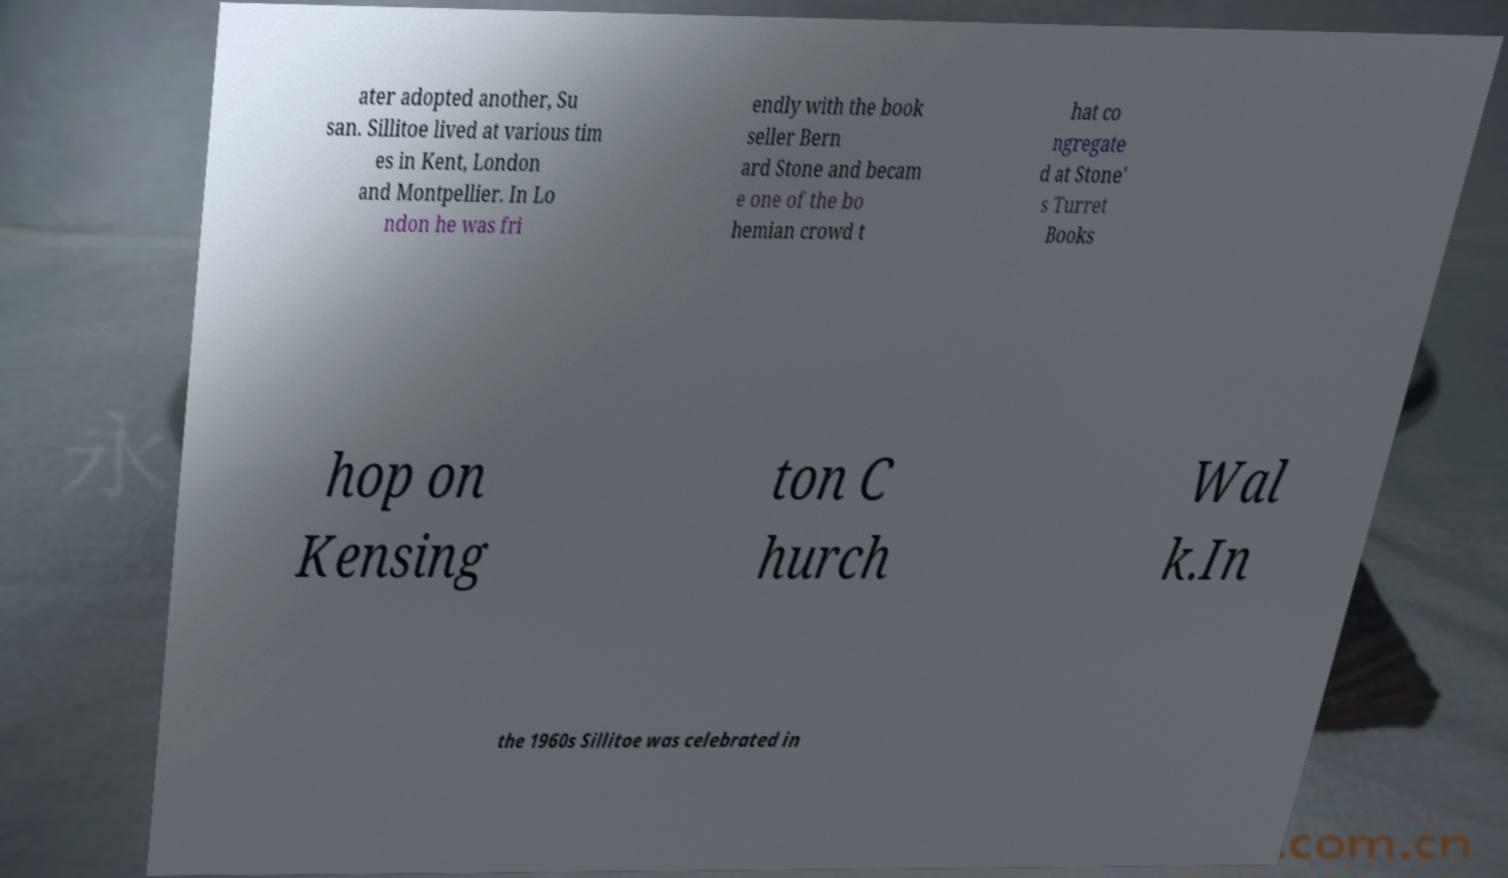There's text embedded in this image that I need extracted. Can you transcribe it verbatim? ater adopted another, Su san. Sillitoe lived at various tim es in Kent, London and Montpellier. In Lo ndon he was fri endly with the book seller Bern ard Stone and becam e one of the bo hemian crowd t hat co ngregate d at Stone' s Turret Books hop on Kensing ton C hurch Wal k.In the 1960s Sillitoe was celebrated in 